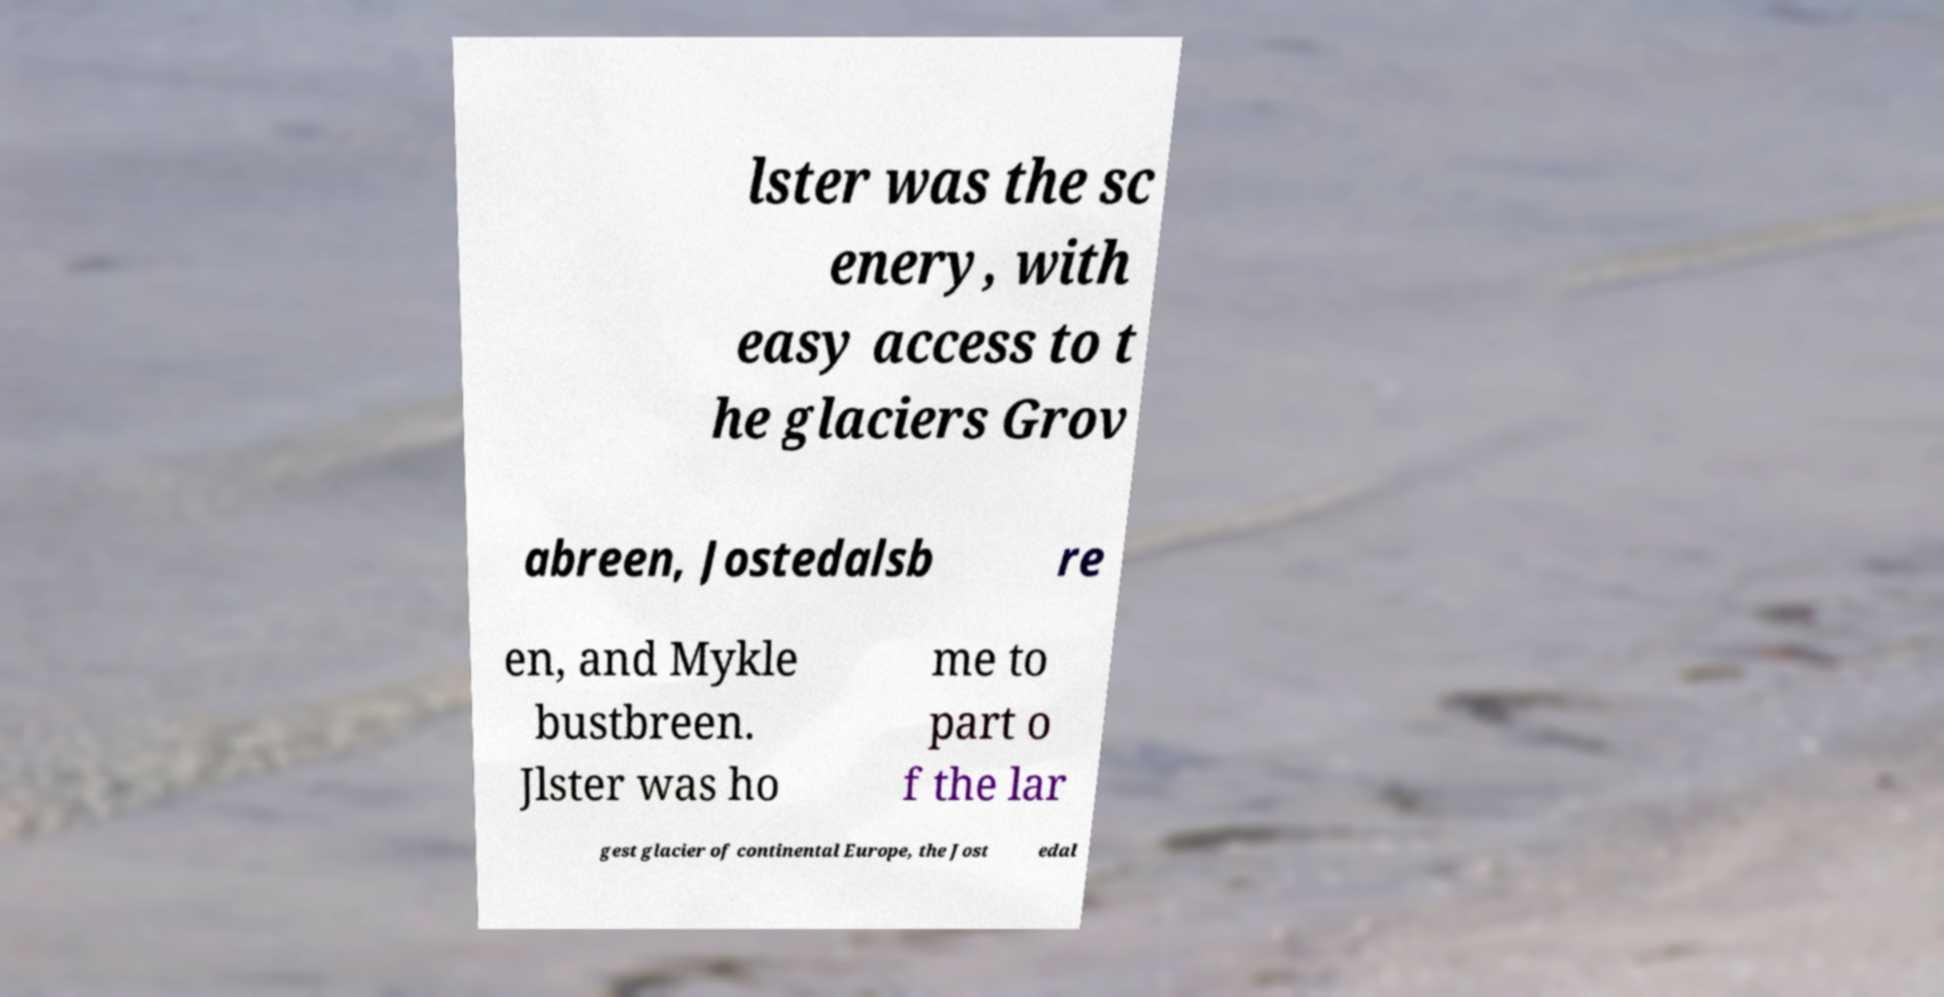Please read and relay the text visible in this image. What does it say? lster was the sc enery, with easy access to t he glaciers Grov abreen, Jostedalsb re en, and Mykle bustbreen. Jlster was ho me to part o f the lar gest glacier of continental Europe, the Jost edal 